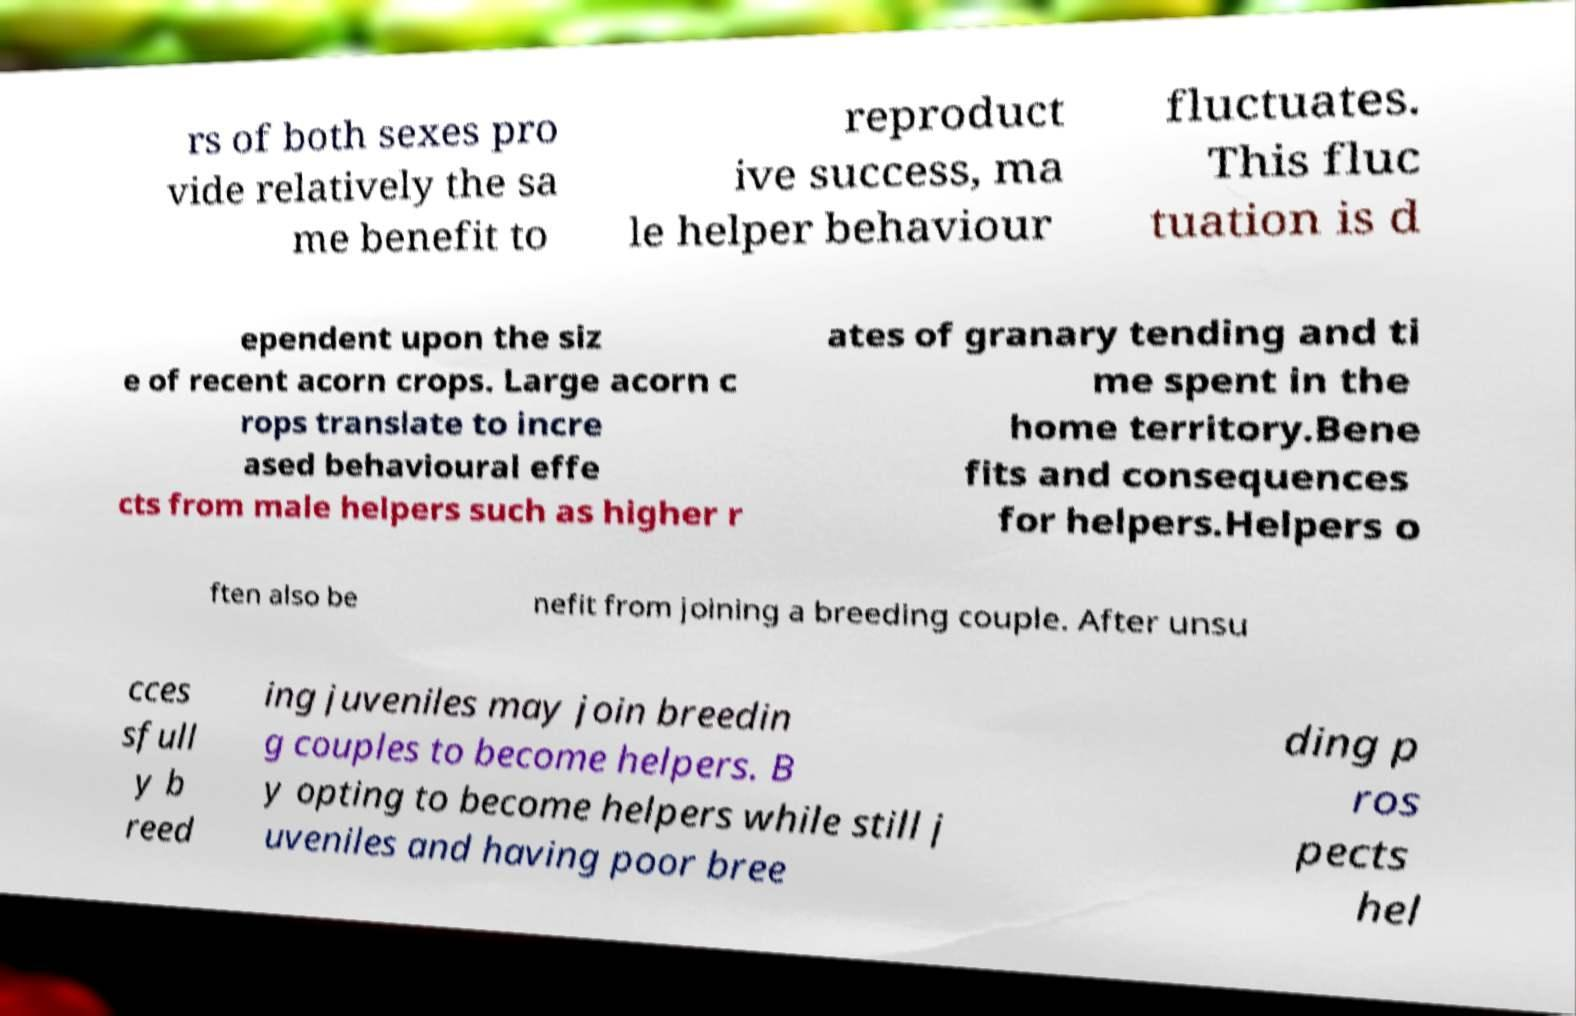Can you accurately transcribe the text from the provided image for me? rs of both sexes pro vide relatively the sa me benefit to reproduct ive success, ma le helper behaviour fluctuates. This fluc tuation is d ependent upon the siz e of recent acorn crops. Large acorn c rops translate to incre ased behavioural effe cts from male helpers such as higher r ates of granary tending and ti me spent in the home territory.Bene fits and consequences for helpers.Helpers o ften also be nefit from joining a breeding couple. After unsu cces sfull y b reed ing juveniles may join breedin g couples to become helpers. B y opting to become helpers while still j uveniles and having poor bree ding p ros pects hel 